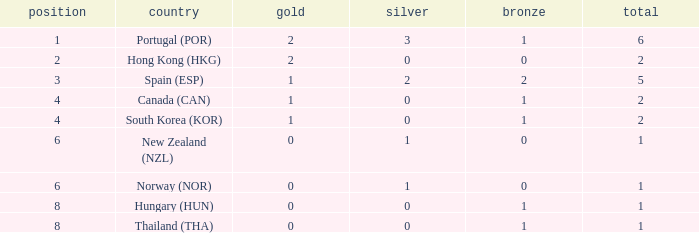What is the lowest Total containing a Bronze of 0 and Rank smaller than 2? None. 